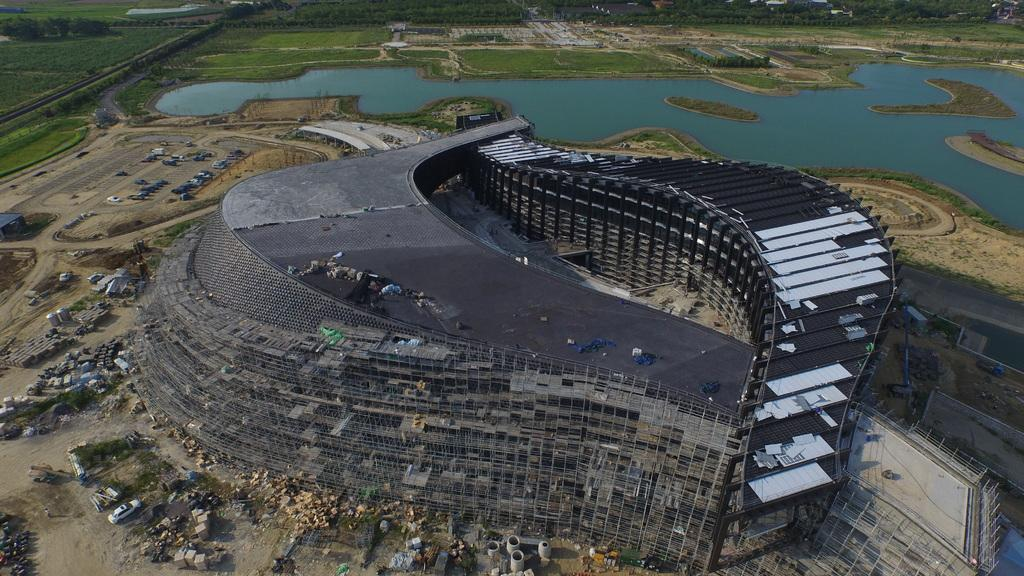What type of structure is present in the image? There is a building in the image. What natural element can be seen in the image? There is water visible in the image. What type of vegetation is present in the image? There is grass in the image. What mode of transportation can be seen in the image? There is a car in the image. How many faces can be seen in the image? There are no faces present in the image. What type of boats are visible in the image? There are no boats present in the image. 